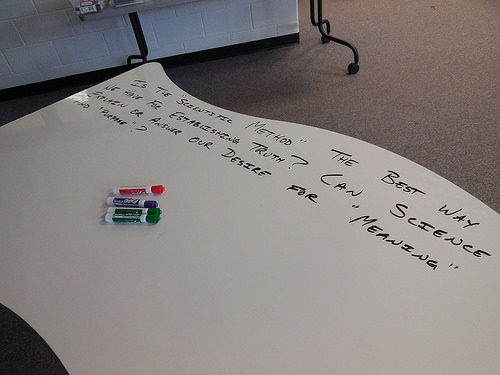<image>
Is the poster on the floor? Yes. Looking at the image, I can see the poster is positioned on top of the floor, with the floor providing support. 